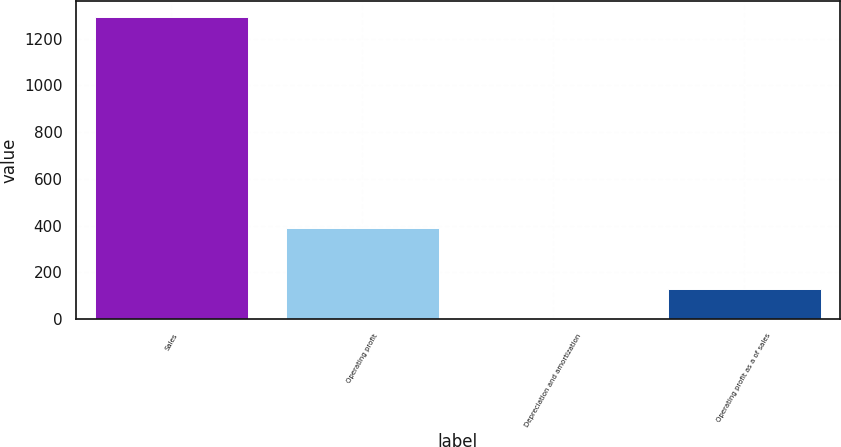<chart> <loc_0><loc_0><loc_500><loc_500><bar_chart><fcel>Sales<fcel>Operating profit<fcel>Depreciation and amortization<fcel>Operating profit as a of sales<nl><fcel>1294.2<fcel>389.38<fcel>1.6<fcel>130.86<nl></chart> 